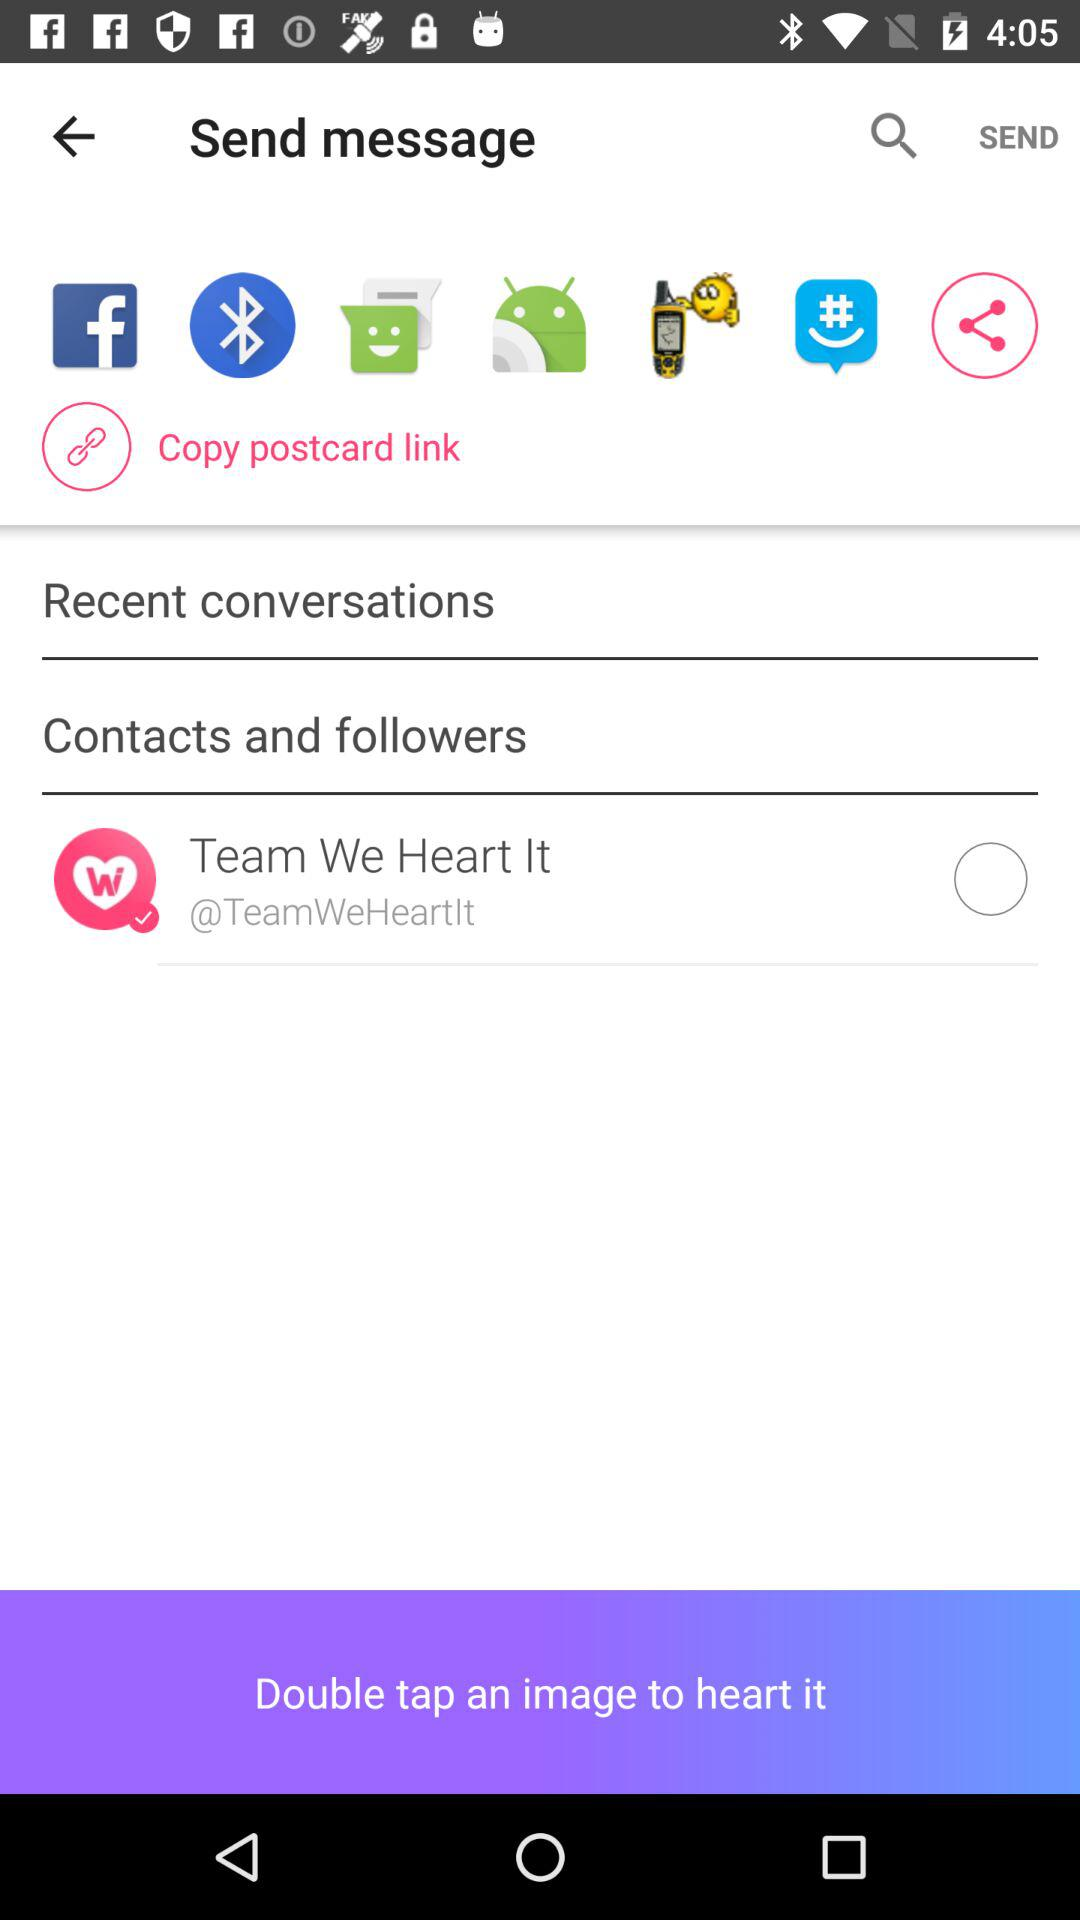What is the user name?
When the provided information is insufficient, respond with <no answer>. <no answer> 